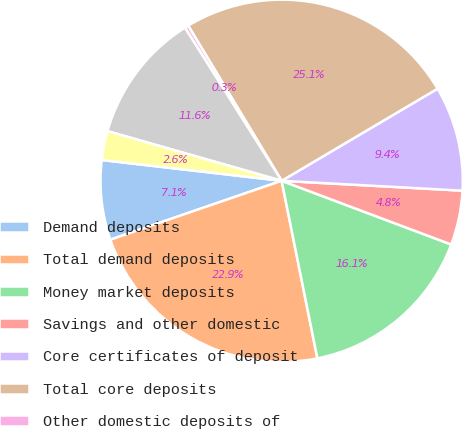Convert chart to OTSL. <chart><loc_0><loc_0><loc_500><loc_500><pie_chart><fcel>Demand deposits<fcel>Total demand deposits<fcel>Money market deposits<fcel>Savings and other domestic<fcel>Core certificates of deposit<fcel>Total core deposits<fcel>Other domestic deposits of<fcel>Brokered deposits and<fcel>Deposits in foreign offices<nl><fcel>7.1%<fcel>22.89%<fcel>16.12%<fcel>4.85%<fcel>9.36%<fcel>25.14%<fcel>0.34%<fcel>11.61%<fcel>2.59%<nl></chart> 